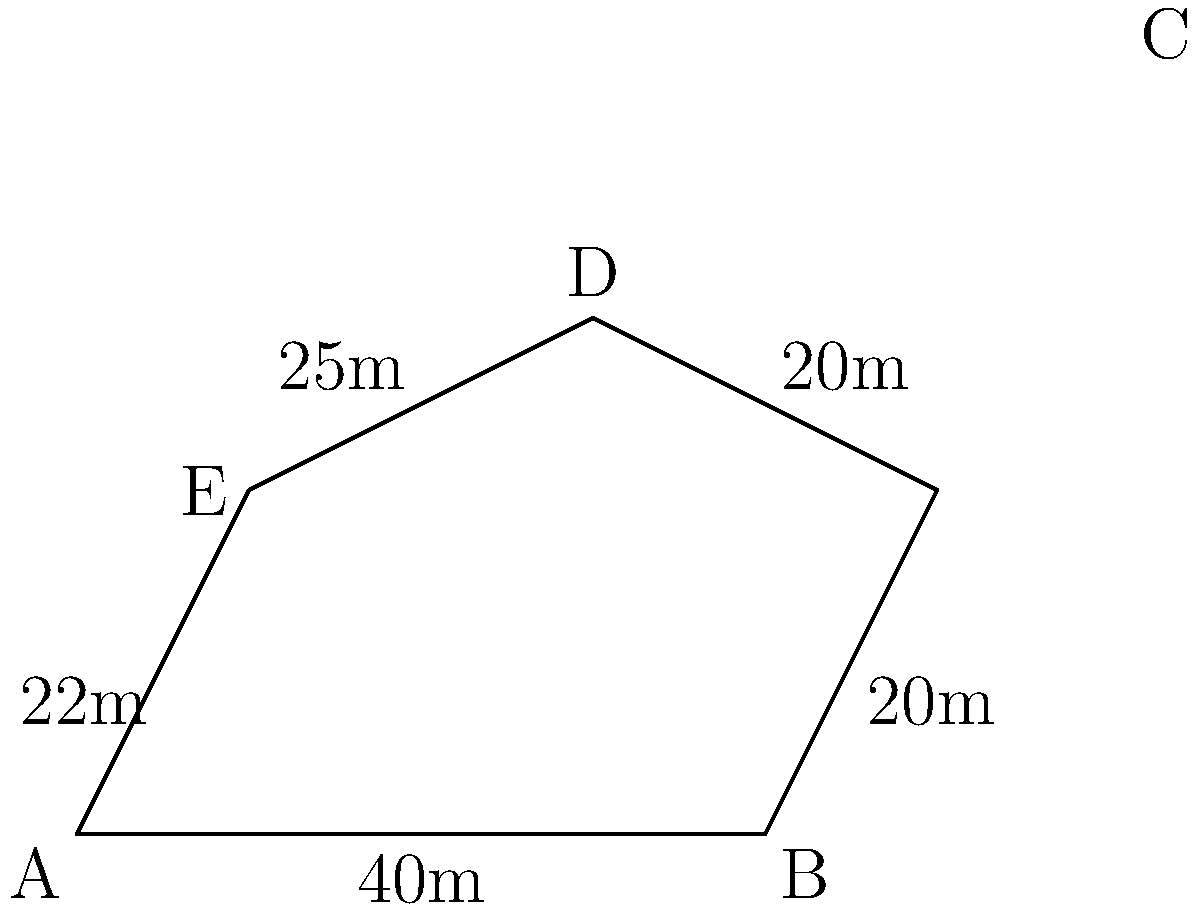At your local stadium in Kinshasa, a new javelin throwing area has been designed with an irregular shape. The dimensions of the sides are given in meters as shown in the diagram. Calculate the perimeter of this javelin throwing area. To find the perimeter of the irregular shape, we need to add up the lengths of all sides:

1) Side AB = 40m
2) Side BC = 20m
3) Side CD = 20m
4) Side DE = 25m
5) Side EA = 22m

Now, let's add all these lengths:

$$\text{Perimeter} = 40 + 20 + 20 + 25 + 22 = 127\text{ meters}$$

Therefore, the perimeter of the javelin throwing area is 127 meters.
Answer: 127 meters 